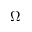<formula> <loc_0><loc_0><loc_500><loc_500>\Omega</formula> 